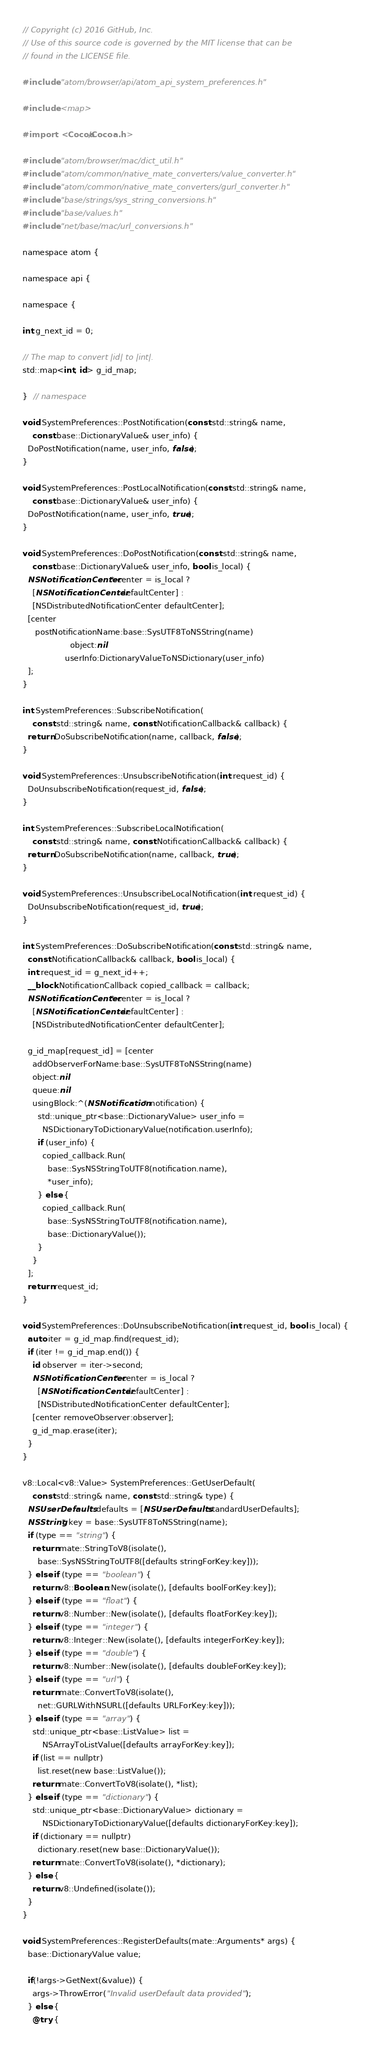<code> <loc_0><loc_0><loc_500><loc_500><_ObjectiveC_>// Copyright (c) 2016 GitHub, Inc.
// Use of this source code is governed by the MIT license that can be
// found in the LICENSE file.

#include "atom/browser/api/atom_api_system_preferences.h"

#include <map>

#import <Cocoa/Cocoa.h>

#include "atom/browser/mac/dict_util.h"
#include "atom/common/native_mate_converters/value_converter.h"
#include "atom/common/native_mate_converters/gurl_converter.h"
#include "base/strings/sys_string_conversions.h"
#include "base/values.h"
#include "net/base/mac/url_conversions.h"

namespace atom {

namespace api {

namespace {

int g_next_id = 0;

// The map to convert |id| to |int|.
std::map<int, id> g_id_map;

}  // namespace

void SystemPreferences::PostNotification(const std::string& name,
    const base::DictionaryValue& user_info) {
  DoPostNotification(name, user_info, false);
}

void SystemPreferences::PostLocalNotification(const std::string& name,
    const base::DictionaryValue& user_info) {
  DoPostNotification(name, user_info, true);
}

void SystemPreferences::DoPostNotification(const std::string& name,
    const base::DictionaryValue& user_info, bool is_local) {
  NSNotificationCenter* center = is_local ?
    [NSNotificationCenter defaultCenter] :
    [NSDistributedNotificationCenter defaultCenter];
  [center
     postNotificationName:base::SysUTF8ToNSString(name)
                   object:nil
                 userInfo:DictionaryValueToNSDictionary(user_info)
  ];
}

int SystemPreferences::SubscribeNotification(
    const std::string& name, const NotificationCallback& callback) {
  return DoSubscribeNotification(name, callback, false);
}

void SystemPreferences::UnsubscribeNotification(int request_id) {
  DoUnsubscribeNotification(request_id, false);
}

int SystemPreferences::SubscribeLocalNotification(
    const std::string& name, const NotificationCallback& callback) {
  return DoSubscribeNotification(name, callback, true);
}

void SystemPreferences::UnsubscribeLocalNotification(int request_id) {
  DoUnsubscribeNotification(request_id, true);
}

int SystemPreferences::DoSubscribeNotification(const std::string& name,
  const NotificationCallback& callback, bool is_local) {
  int request_id = g_next_id++;
  __block NotificationCallback copied_callback = callback;
  NSNotificationCenter* center = is_local ?
    [NSNotificationCenter defaultCenter] :
    [NSDistributedNotificationCenter defaultCenter];

  g_id_map[request_id] = [center
    addObserverForName:base::SysUTF8ToNSString(name)
    object:nil
    queue:nil
    usingBlock:^(NSNotification* notification) {
      std::unique_ptr<base::DictionaryValue> user_info =
        NSDictionaryToDictionaryValue(notification.userInfo);
      if (user_info) {
        copied_callback.Run(
          base::SysNSStringToUTF8(notification.name),
          *user_info);
      } else {
        copied_callback.Run(
          base::SysNSStringToUTF8(notification.name),
          base::DictionaryValue());
      }
    }
  ];
  return request_id;
}

void SystemPreferences::DoUnsubscribeNotification(int request_id, bool is_local) {
  auto iter = g_id_map.find(request_id);
  if (iter != g_id_map.end()) {
    id observer = iter->second;
    NSNotificationCenter* center = is_local ?
      [NSNotificationCenter defaultCenter] :
      [NSDistributedNotificationCenter defaultCenter];
    [center removeObserver:observer];
    g_id_map.erase(iter);
  }
}

v8::Local<v8::Value> SystemPreferences::GetUserDefault(
    const std::string& name, const std::string& type) {
  NSUserDefaults* defaults = [NSUserDefaults standardUserDefaults];
  NSString* key = base::SysUTF8ToNSString(name);
  if (type == "string") {
    return mate::StringToV8(isolate(),
      base::SysNSStringToUTF8([defaults stringForKey:key]));
  } else if (type == "boolean") {
    return v8::Boolean::New(isolate(), [defaults boolForKey:key]);
  } else if (type == "float") {
    return v8::Number::New(isolate(), [defaults floatForKey:key]);
  } else if (type == "integer") {
    return v8::Integer::New(isolate(), [defaults integerForKey:key]);
  } else if (type == "double") {
    return v8::Number::New(isolate(), [defaults doubleForKey:key]);
  } else if (type == "url") {
    return mate::ConvertToV8(isolate(),
      net::GURLWithNSURL([defaults URLForKey:key]));
  } else if (type == "array") {
    std::unique_ptr<base::ListValue> list =
        NSArrayToListValue([defaults arrayForKey:key]);
    if (list == nullptr)
      list.reset(new base::ListValue());
    return mate::ConvertToV8(isolate(), *list);
  } else if (type == "dictionary") {
    std::unique_ptr<base::DictionaryValue> dictionary =
        NSDictionaryToDictionaryValue([defaults dictionaryForKey:key]);
    if (dictionary == nullptr)
      dictionary.reset(new base::DictionaryValue());
    return mate::ConvertToV8(isolate(), *dictionary);
  } else {
    return v8::Undefined(isolate());
  }
}

void SystemPreferences::RegisterDefaults(mate::Arguments* args) {
  base::DictionaryValue value;

  if(!args->GetNext(&value)) {
    args->ThrowError("Invalid userDefault data provided");
  } else {
    @try {</code> 